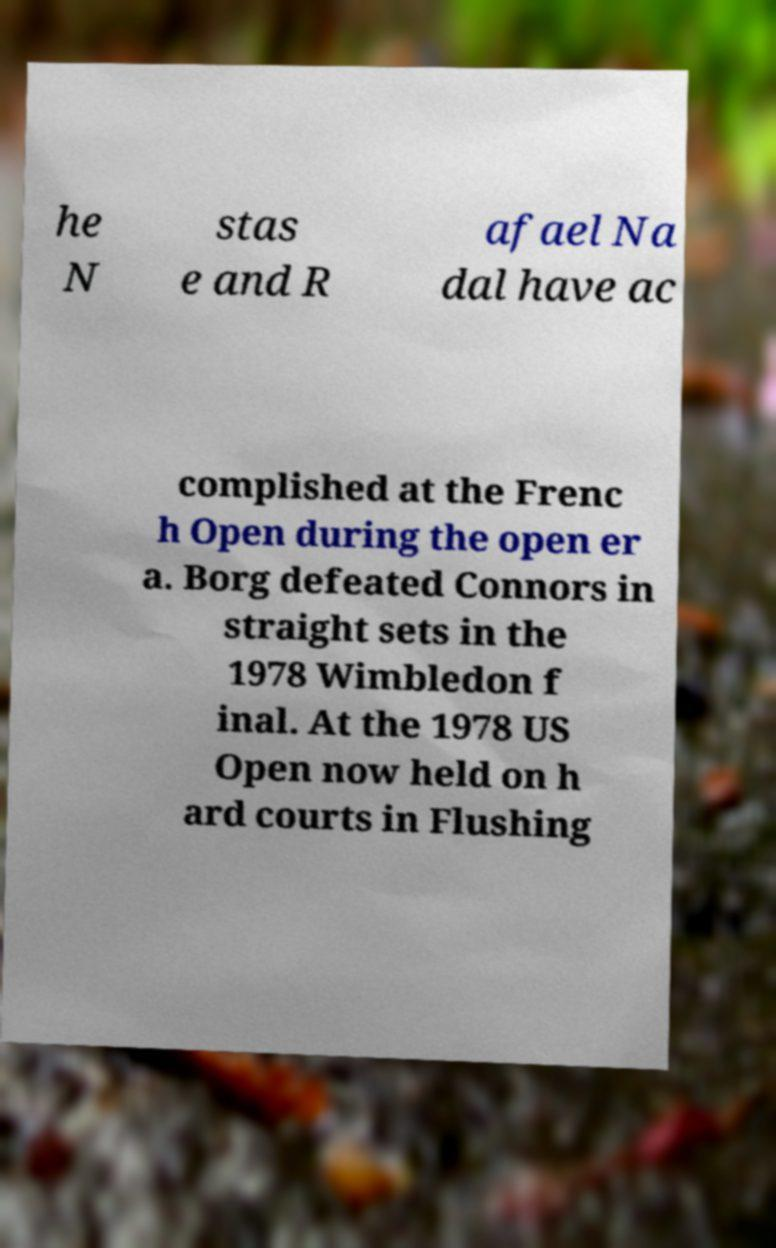Can you read and provide the text displayed in the image?This photo seems to have some interesting text. Can you extract and type it out for me? he N stas e and R afael Na dal have ac complished at the Frenc h Open during the open er a. Borg defeated Connors in straight sets in the 1978 Wimbledon f inal. At the 1978 US Open now held on h ard courts in Flushing 